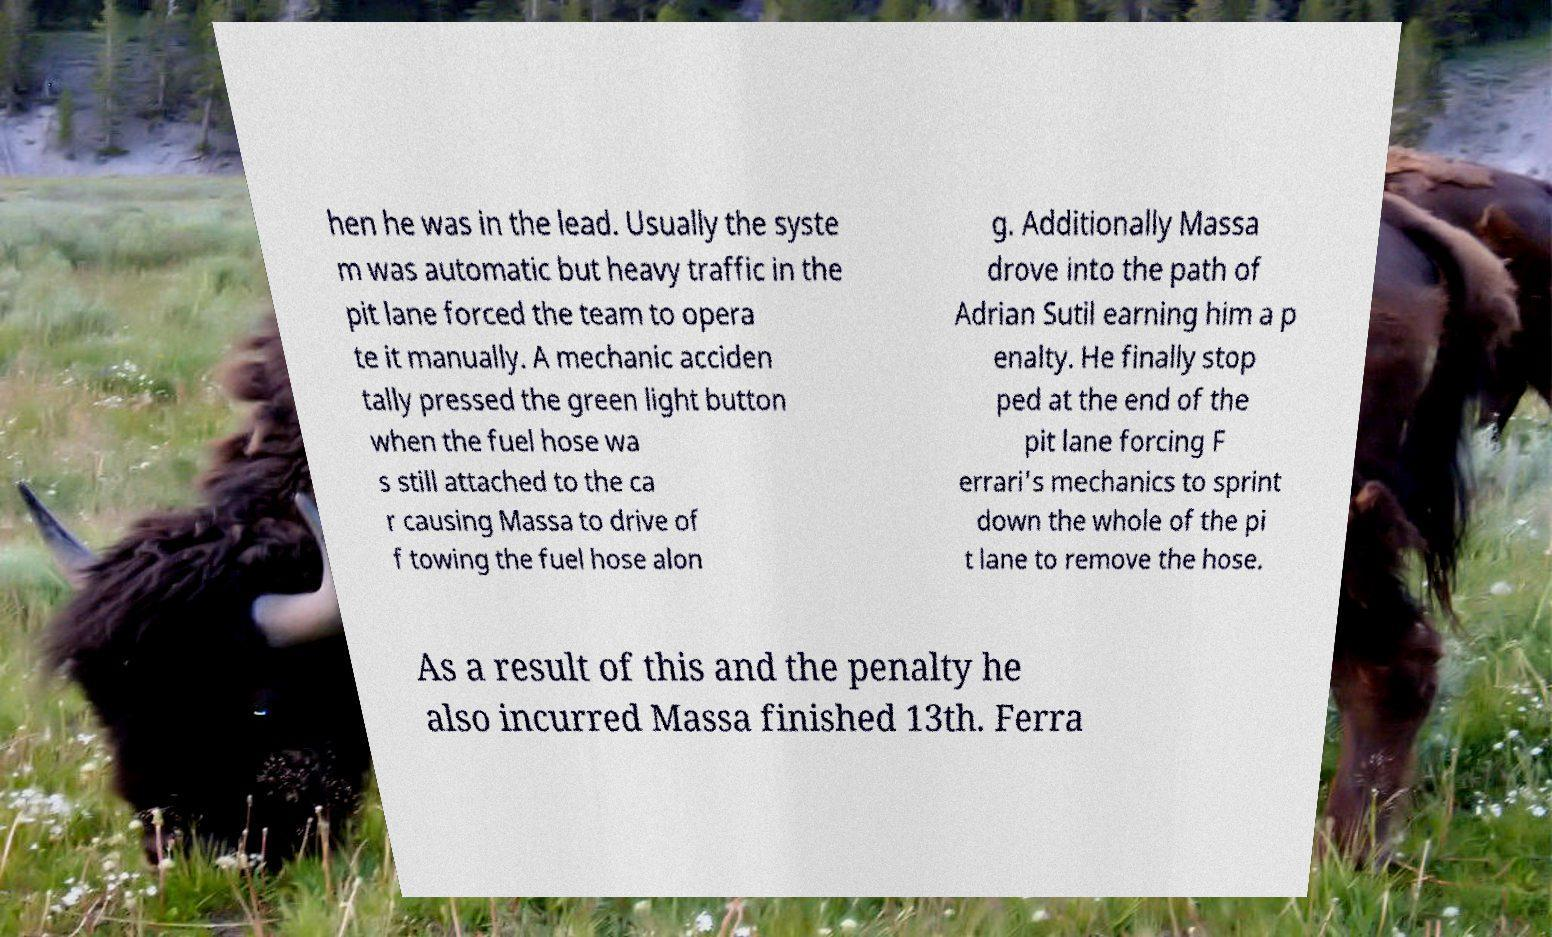Please identify and transcribe the text found in this image. hen he was in the lead. Usually the syste m was automatic but heavy traffic in the pit lane forced the team to opera te it manually. A mechanic acciden tally pressed the green light button when the fuel hose wa s still attached to the ca r causing Massa to drive of f towing the fuel hose alon g. Additionally Massa drove into the path of Adrian Sutil earning him a p enalty. He finally stop ped at the end of the pit lane forcing F errari's mechanics to sprint down the whole of the pi t lane to remove the hose. As a result of this and the penalty he also incurred Massa finished 13th. Ferra 